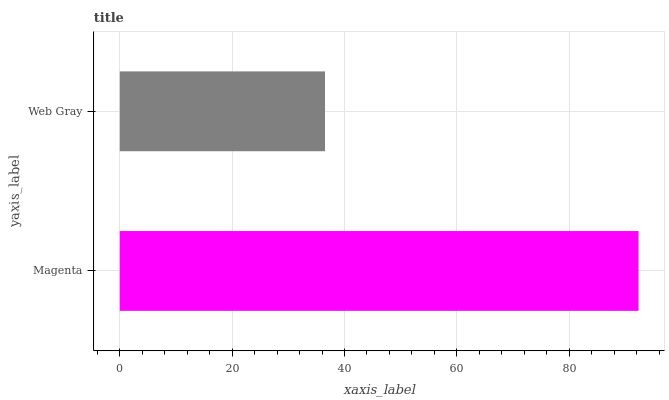Is Web Gray the minimum?
Answer yes or no. Yes. Is Magenta the maximum?
Answer yes or no. Yes. Is Web Gray the maximum?
Answer yes or no. No. Is Magenta greater than Web Gray?
Answer yes or no. Yes. Is Web Gray less than Magenta?
Answer yes or no. Yes. Is Web Gray greater than Magenta?
Answer yes or no. No. Is Magenta less than Web Gray?
Answer yes or no. No. Is Magenta the high median?
Answer yes or no. Yes. Is Web Gray the low median?
Answer yes or no. Yes. Is Web Gray the high median?
Answer yes or no. No. Is Magenta the low median?
Answer yes or no. No. 